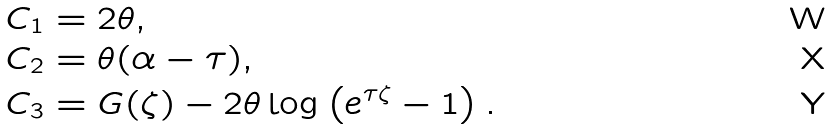<formula> <loc_0><loc_0><loc_500><loc_500>C _ { 1 } & = 2 \theta , \\ C _ { 2 } & = \theta ( \alpha - \tau ) , \\ C _ { 3 } & = G ( \zeta ) - 2 \theta \log \left ( e ^ { \tau \zeta } - 1 \right ) .</formula> 